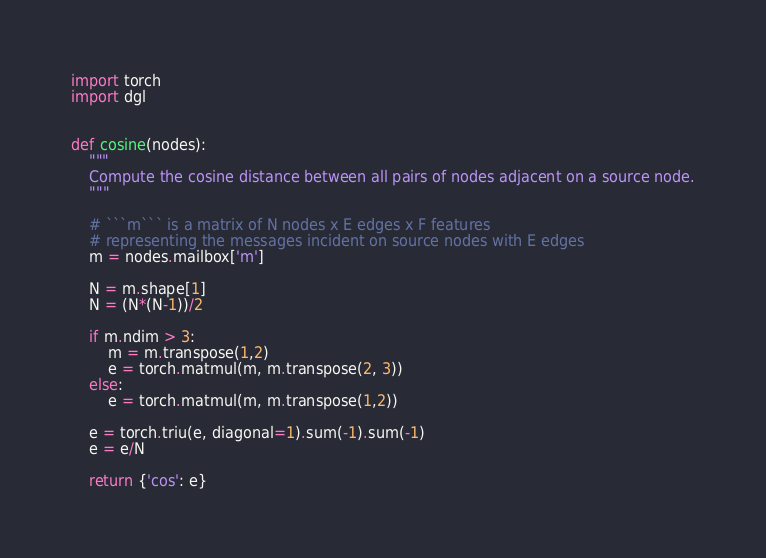<code> <loc_0><loc_0><loc_500><loc_500><_Python_>import torch
import dgl


def cosine(nodes):
    """
    Compute the cosine distance between all pairs of nodes adjacent on a source node.
    """

    # ```m``` is a matrix of N nodes x E edges x F features
    # representing the messages incident on source nodes with E edges
    m = nodes.mailbox['m']

    N = m.shape[1]
    N = (N*(N-1))/2

    if m.ndim > 3:
        m = m.transpose(1,2)
        e = torch.matmul(m, m.transpose(2, 3))
    else:
        e = torch.matmul(m, m.transpose(1,2))

    e = torch.triu(e, diagonal=1).sum(-1).sum(-1)
    e = e/N

    return {'cos': e}
</code> 